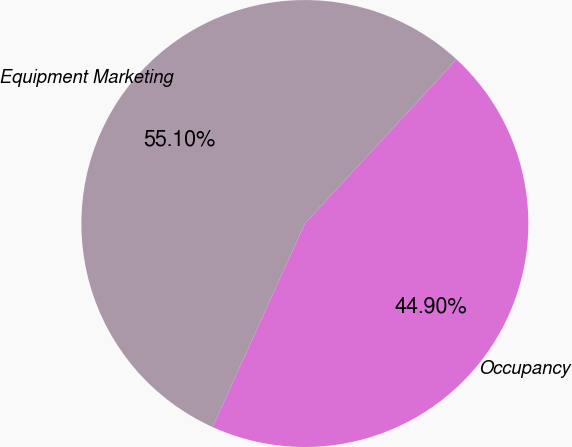<chart> <loc_0><loc_0><loc_500><loc_500><pie_chart><fcel>Occupancy<fcel>Equipment Marketing<nl><fcel>44.9%<fcel>55.1%<nl></chart> 